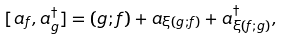<formula> <loc_0><loc_0><loc_500><loc_500>[ a _ { f } , a _ { g } ^ { \dagger } ] = ( g ; f ) + a _ { \xi ( g ; f ) } + a _ { \xi ( f ; g ) } ^ { \dagger } ,</formula> 